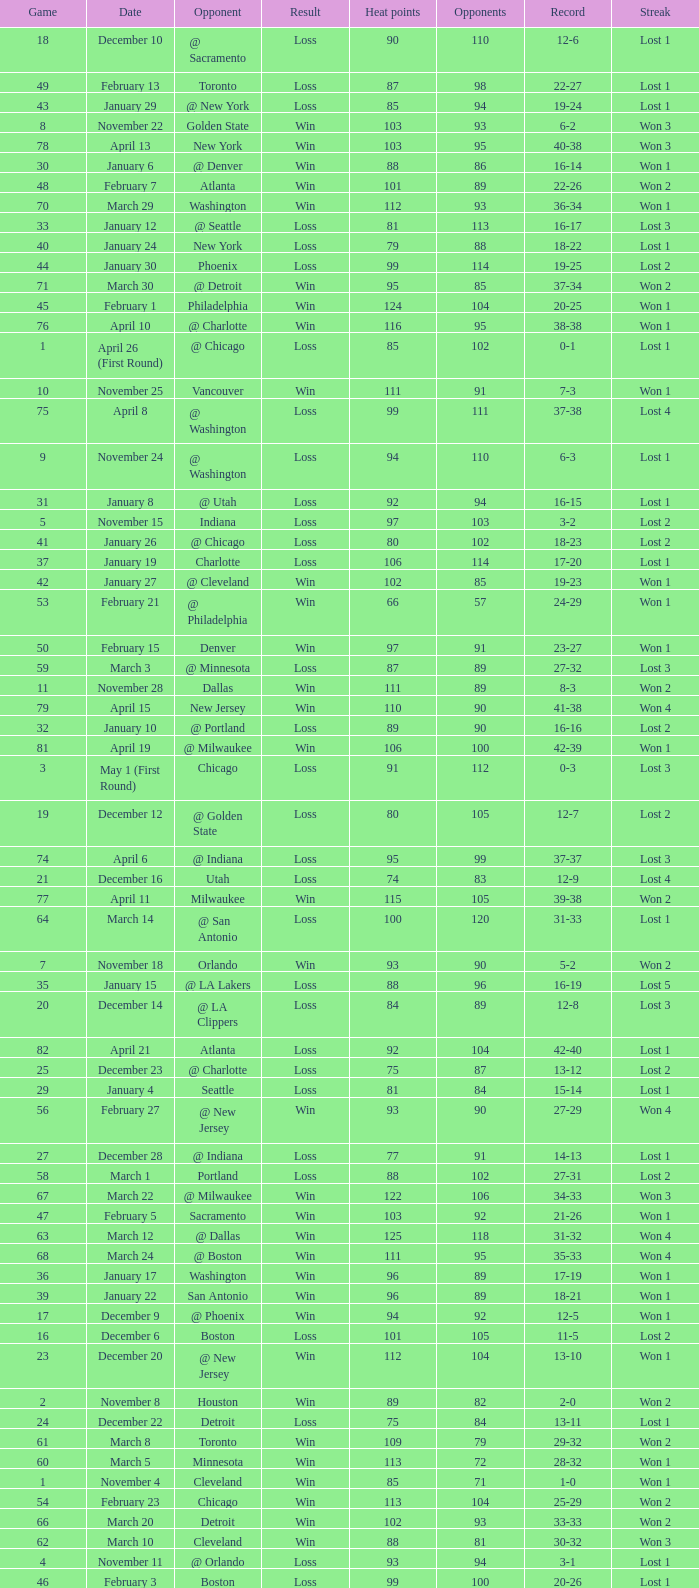What is the highest Game, when Opponents is less than 80, and when Record is "1-0"? 1.0. Write the full table. {'header': ['Game', 'Date', 'Opponent', 'Result', 'Heat points', 'Opponents', 'Record', 'Streak'], 'rows': [['18', 'December 10', '@ Sacramento', 'Loss', '90', '110', '12-6', 'Lost 1'], ['49', 'February 13', 'Toronto', 'Loss', '87', '98', '22-27', 'Lost 1'], ['43', 'January 29', '@ New York', 'Loss', '85', '94', '19-24', 'Lost 1'], ['8', 'November 22', 'Golden State', 'Win', '103', '93', '6-2', 'Won 3'], ['78', 'April 13', 'New York', 'Win', '103', '95', '40-38', 'Won 3'], ['30', 'January 6', '@ Denver', 'Win', '88', '86', '16-14', 'Won 1'], ['48', 'February 7', 'Atlanta', 'Win', '101', '89', '22-26', 'Won 2'], ['70', 'March 29', 'Washington', 'Win', '112', '93', '36-34', 'Won 1'], ['33', 'January 12', '@ Seattle', 'Loss', '81', '113', '16-17', 'Lost 3'], ['40', 'January 24', 'New York', 'Loss', '79', '88', '18-22', 'Lost 1'], ['44', 'January 30', 'Phoenix', 'Loss', '99', '114', '19-25', 'Lost 2'], ['71', 'March 30', '@ Detroit', 'Win', '95', '85', '37-34', 'Won 2'], ['45', 'February 1', 'Philadelphia', 'Win', '124', '104', '20-25', 'Won 1'], ['76', 'April 10', '@ Charlotte', 'Win', '116', '95', '38-38', 'Won 1'], ['1', 'April 26 (First Round)', '@ Chicago', 'Loss', '85', '102', '0-1', 'Lost 1'], ['10', 'November 25', 'Vancouver', 'Win', '111', '91', '7-3', 'Won 1'], ['75', 'April 8', '@ Washington', 'Loss', '99', '111', '37-38', 'Lost 4'], ['9', 'November 24', '@ Washington', 'Loss', '94', '110', '6-3', 'Lost 1'], ['31', 'January 8', '@ Utah', 'Loss', '92', '94', '16-15', 'Lost 1'], ['5', 'November 15', 'Indiana', 'Loss', '97', '103', '3-2', 'Lost 2'], ['41', 'January 26', '@ Chicago', 'Loss', '80', '102', '18-23', 'Lost 2'], ['37', 'January 19', 'Charlotte', 'Loss', '106', '114', '17-20', 'Lost 1'], ['42', 'January 27', '@ Cleveland', 'Win', '102', '85', '19-23', 'Won 1'], ['53', 'February 21', '@ Philadelphia', 'Win', '66', '57', '24-29', 'Won 1'], ['50', 'February 15', 'Denver', 'Win', '97', '91', '23-27', 'Won 1'], ['59', 'March 3', '@ Minnesota', 'Loss', '87', '89', '27-32', 'Lost 3'], ['11', 'November 28', 'Dallas', 'Win', '111', '89', '8-3', 'Won 2'], ['79', 'April 15', 'New Jersey', 'Win', '110', '90', '41-38', 'Won 4'], ['32', 'January 10', '@ Portland', 'Loss', '89', '90', '16-16', 'Lost 2'], ['81', 'April 19', '@ Milwaukee', 'Win', '106', '100', '42-39', 'Won 1'], ['3', 'May 1 (First Round)', 'Chicago', 'Loss', '91', '112', '0-3', 'Lost 3'], ['19', 'December 12', '@ Golden State', 'Loss', '80', '105', '12-7', 'Lost 2'], ['74', 'April 6', '@ Indiana', 'Loss', '95', '99', '37-37', 'Lost 3'], ['21', 'December 16', 'Utah', 'Loss', '74', '83', '12-9', 'Lost 4'], ['77', 'April 11', 'Milwaukee', 'Win', '115', '105', '39-38', 'Won 2'], ['64', 'March 14', '@ San Antonio', 'Loss', '100', '120', '31-33', 'Lost 1'], ['7', 'November 18', 'Orlando', 'Win', '93', '90', '5-2', 'Won 2'], ['35', 'January 15', '@ LA Lakers', 'Loss', '88', '96', '16-19', 'Lost 5'], ['20', 'December 14', '@ LA Clippers', 'Loss', '84', '89', '12-8', 'Lost 3'], ['82', 'April 21', 'Atlanta', 'Loss', '92', '104', '42-40', 'Lost 1'], ['25', 'December 23', '@ Charlotte', 'Loss', '75', '87', '13-12', 'Lost 2'], ['29', 'January 4', 'Seattle', 'Loss', '81', '84', '15-14', 'Lost 1'], ['56', 'February 27', '@ New Jersey', 'Win', '93', '90', '27-29', 'Won 4'], ['27', 'December 28', '@ Indiana', 'Loss', '77', '91', '14-13', 'Lost 1'], ['58', 'March 1', 'Portland', 'Loss', '88', '102', '27-31', 'Lost 2'], ['67', 'March 22', '@ Milwaukee', 'Win', '122', '106', '34-33', 'Won 3'], ['47', 'February 5', 'Sacramento', 'Win', '103', '92', '21-26', 'Won 1'], ['63', 'March 12', '@ Dallas', 'Win', '125', '118', '31-32', 'Won 4'], ['68', 'March 24', '@ Boston', 'Win', '111', '95', '35-33', 'Won 4'], ['36', 'January 17', 'Washington', 'Win', '96', '89', '17-19', 'Won 1'], ['39', 'January 22', 'San Antonio', 'Win', '96', '89', '18-21', 'Won 1'], ['17', 'December 9', '@ Phoenix', 'Win', '94', '92', '12-5', 'Won 1'], ['16', 'December 6', 'Boston', 'Loss', '101', '105', '11-5', 'Lost 2'], ['23', 'December 20', '@ New Jersey', 'Win', '112', '104', '13-10', 'Won 1'], ['2', 'November 8', 'Houston', 'Win', '89', '82', '2-0', 'Won 2'], ['24', 'December 22', 'Detroit', 'Loss', '75', '84', '13-11', 'Lost 1'], ['61', 'March 8', 'Toronto', 'Win', '109', '79', '29-32', 'Won 2'], ['60', 'March 5', 'Minnesota', 'Win', '113', '72', '28-32', 'Won 1'], ['1', 'November 4', 'Cleveland', 'Win', '85', '71', '1-0', 'Won 1'], ['54', 'February 23', 'Chicago', 'Win', '113', '104', '25-29', 'Won 2'], ['66', 'March 20', 'Detroit', 'Win', '102', '93', '33-33', 'Won 2'], ['62', 'March 10', 'Cleveland', 'Win', '88', '81', '30-32', 'Won 3'], ['4', 'November 11', '@ Orlando', 'Loss', '93', '94', '3-1', 'Lost 1'], ['46', 'February 3', 'Boston', 'Loss', '99', '100', '20-26', 'Lost 1'], ['3', 'November 10', 'New Jersey', 'Win', '106', '80', '3-0', 'Won 3'], ['65', 'March 16', '@ Houston', 'Win', '121', '97', '32-33', 'Won 1'], ['57', 'February 28', '@ Orlando', 'Loss', '112', '116', '27-30', 'Lost 1'], ['12', 'November 30', '@ Detroit', 'Win', '118', '107', '9-3', 'Won 3'], ['22', 'December 19', '@ New York', 'Loss', '70', '89', '12-10', 'Lost 5'], ['28', 'December 30', 'LA Clippers', 'Win', '105', '96', '15-13', 'Won 1'], ['6', 'November 17', '@ Atlanta', 'Win', '91', '88', '4-2', 'Won 1'], ['13', 'December 1', 'Charlotte', 'Win', '108', '101', '10-3', 'Won 4'], ['69', 'March 27', 'LA Lakers', 'Loss', '95', '106', '35-34', 'Lost 1'], ['72', 'April 2', 'Chicago', 'Loss', '92', '110', '37-35', 'Lost 1'], ['52', 'February 19', '@ Cleveland', 'Loss', '70', '73', '23-29', 'Lost 2'], ['51', 'February 17', 'Orlando', 'Loss', '93', '95', '23-28', 'Lost 1'], ['15', 'December 4', '@ Boston', 'Loss', '120', '121', '11-4', 'Lost 1'], ['55', 'February 25', 'Philadelphia', 'Win', '108', '101', '26-29', 'Won 3'], ['14', 'December 3', '@ Toronto', 'Win', '112', '94', '11-3', 'Won 5'], ['80', 'April 17', '@ Philadelphia', 'Loss', '86', '90', '41-39', 'Lost 1'], ['73', 'April 4', '@ Chicago', 'Loss', '92', '100', '37-36', 'Lost 2'], ['34', 'January 13', '@ Vancouver', 'Loss', '65', '69', '16-18', 'Lost 4'], ['2', 'April 28 (First Round)', '@ Chicago', 'Loss', '75', '106', '0-2', 'Lost 2'], ['38', 'January 20', '@ Atlanta', 'Loss', '78', '98', '17-21', 'Lost 2'], ['26', 'December 26', 'New Jersey', 'Win', '96', '93', '14-12', 'Won 1']]} 